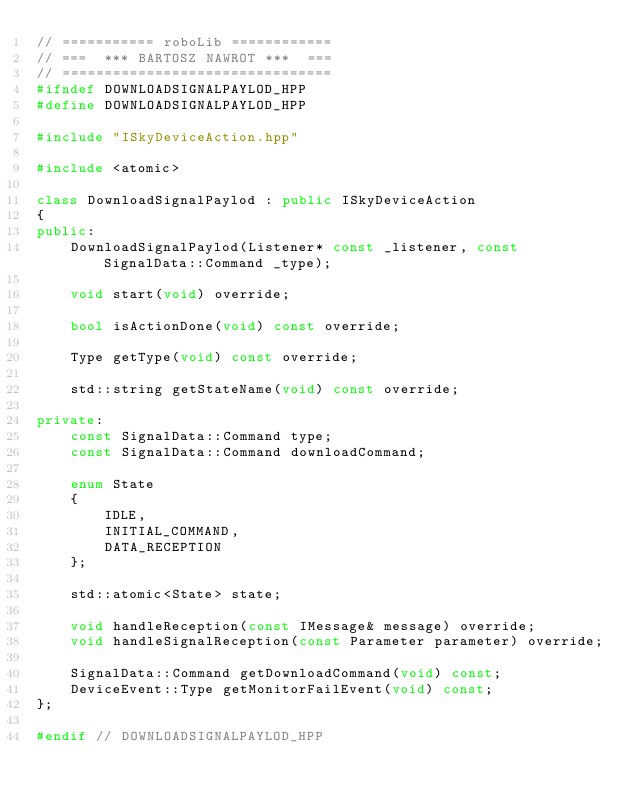<code> <loc_0><loc_0><loc_500><loc_500><_C++_>// =========== roboLib ============
// ===  *** BARTOSZ NAWROT ***  ===
// ================================
#ifndef DOWNLOADSIGNALPAYLOD_HPP
#define DOWNLOADSIGNALPAYLOD_HPP

#include "ISkyDeviceAction.hpp"

#include <atomic>

class DownloadSignalPaylod : public ISkyDeviceAction
{
public:
    DownloadSignalPaylod(Listener* const _listener, const SignalData::Command _type);

    void start(void) override;

    bool isActionDone(void) const override;

    Type getType(void) const override;

    std::string getStateName(void) const override;

private:
    const SignalData::Command type;
    const SignalData::Command downloadCommand;

    enum State
    {
        IDLE,
        INITIAL_COMMAND,
        DATA_RECEPTION
    };

    std::atomic<State> state;

    void handleReception(const IMessage& message) override;
    void handleSignalReception(const Parameter parameter) override;

    SignalData::Command getDownloadCommand(void) const;
    DeviceEvent::Type getMonitorFailEvent(void) const;
};

#endif // DOWNLOADSIGNALPAYLOD_HPP
</code> 